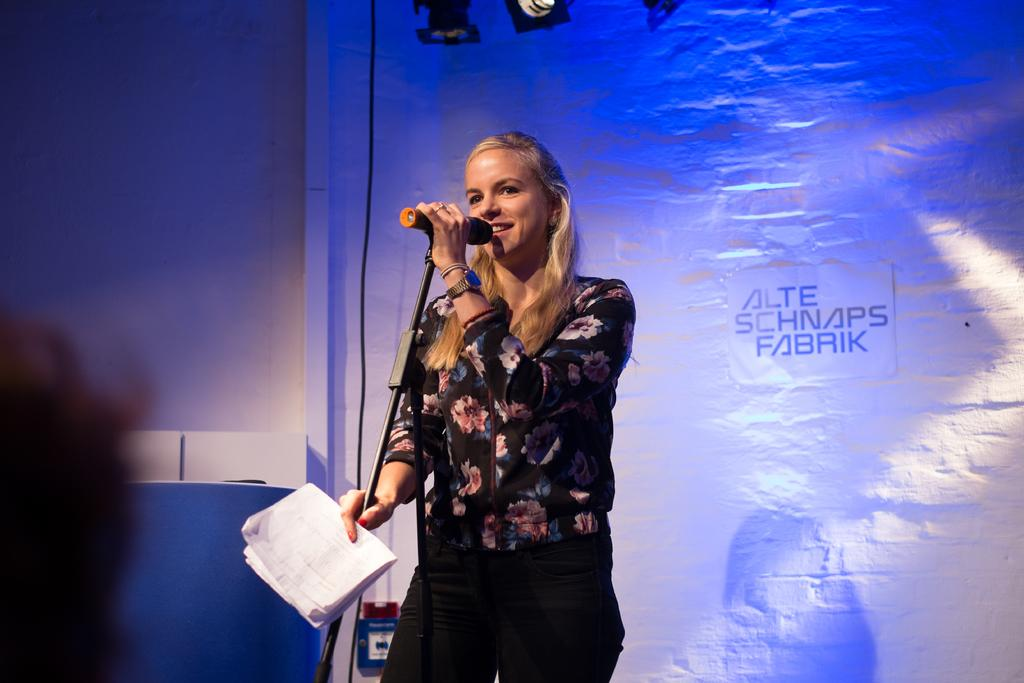Who is the main subject in the image? There is a woman in the image. What is the woman doing in the image? The woman is speaking on a microphone. What else is the woman holding in the image? The woman is holding papers in her hand. What can be seen in the background of the image? There is a banner in the image with text on it. What type of oil is being used to lubricate the woman's foot in the image? There is no mention of a foot or oil in the image; the woman is holding papers and speaking on a microphone. 